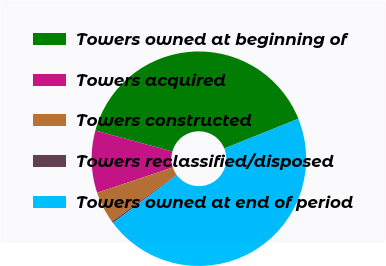Convert chart. <chart><loc_0><loc_0><loc_500><loc_500><pie_chart><fcel>Towers owned at beginning of<fcel>Towers acquired<fcel>Towers constructed<fcel>Towers reclassified/disposed<fcel>Towers owned at end of period<nl><fcel>39.69%<fcel>9.38%<fcel>4.82%<fcel>0.26%<fcel>45.85%<nl></chart> 